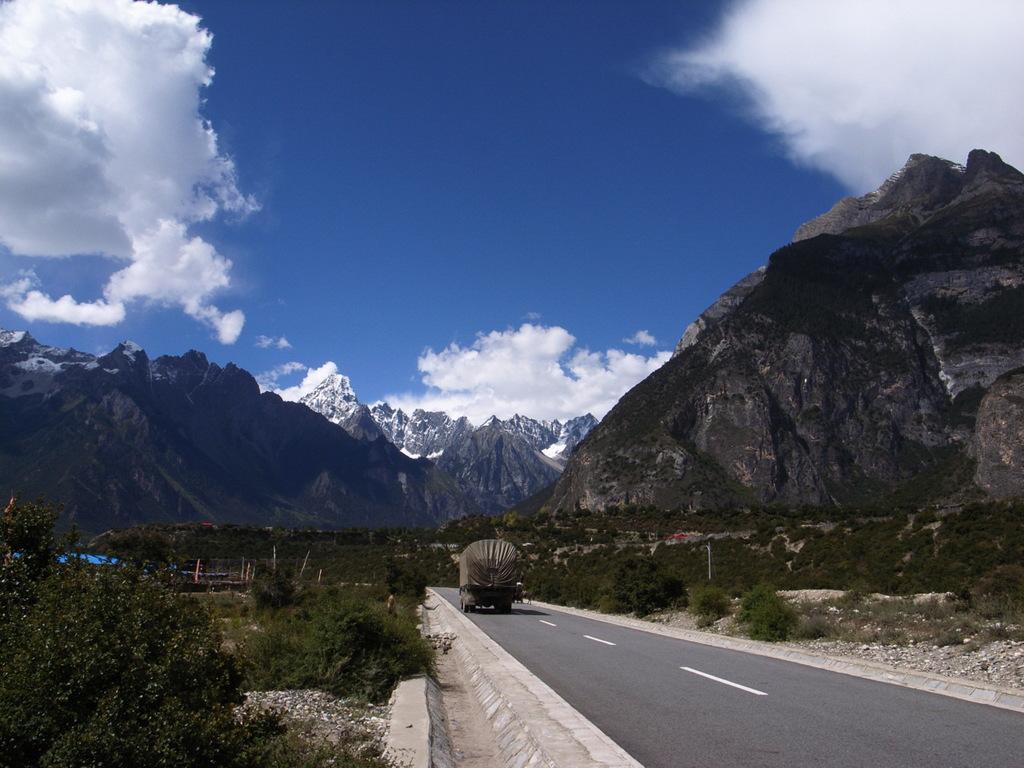Can you describe this image briefly? In this image we can see a motor vehicle on the road, bushes, tents, trees, stones, hills, mountains and sky with clouds. 